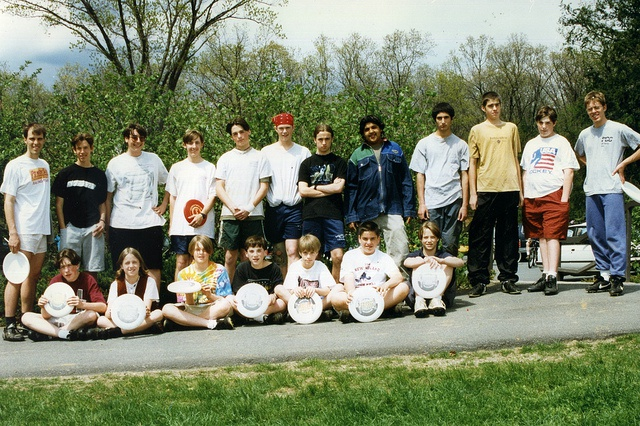Describe the objects in this image and their specific colors. I can see people in beige, white, black, olive, and tan tones, people in beige, black, khaki, and tan tones, people in beige, lightgray, black, and gray tones, people in beige, lightgray, black, and darkgray tones, and people in beige, black, navy, blue, and lightgray tones in this image. 